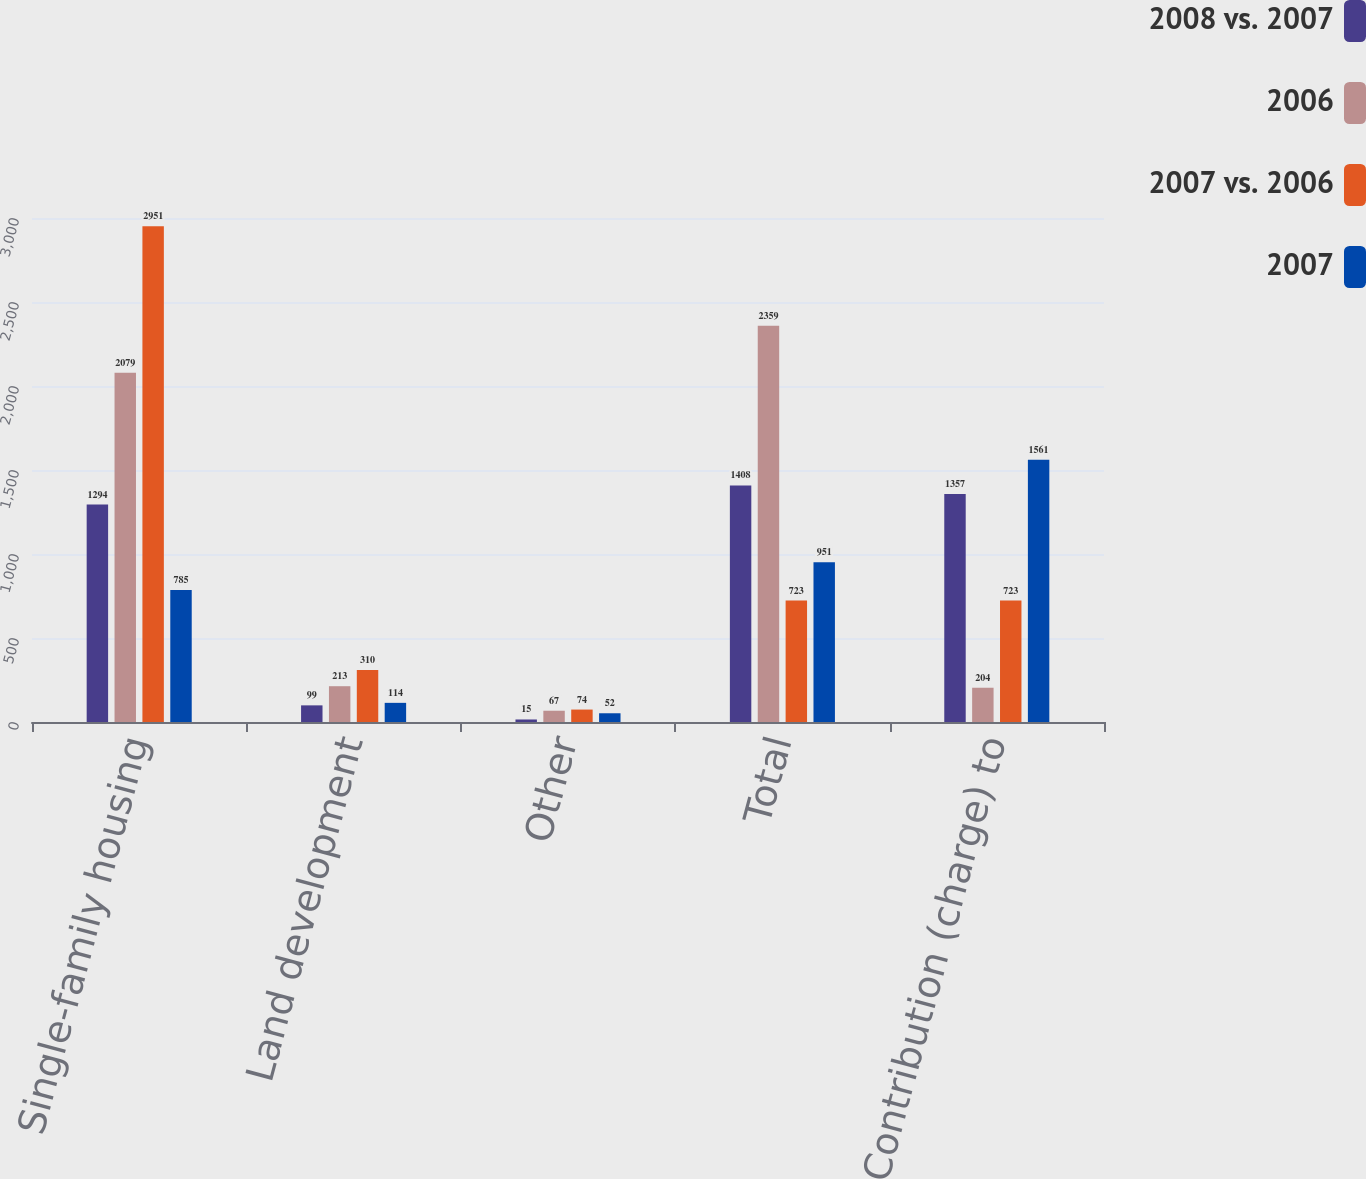Convert chart to OTSL. <chart><loc_0><loc_0><loc_500><loc_500><stacked_bar_chart><ecel><fcel>Single-family housing<fcel>Land development<fcel>Other<fcel>Total<fcel>Contribution (charge) to<nl><fcel>2008 vs. 2007<fcel>1294<fcel>99<fcel>15<fcel>1408<fcel>1357<nl><fcel>2006<fcel>2079<fcel>213<fcel>67<fcel>2359<fcel>204<nl><fcel>2007 vs. 2006<fcel>2951<fcel>310<fcel>74<fcel>723<fcel>723<nl><fcel>2007<fcel>785<fcel>114<fcel>52<fcel>951<fcel>1561<nl></chart> 